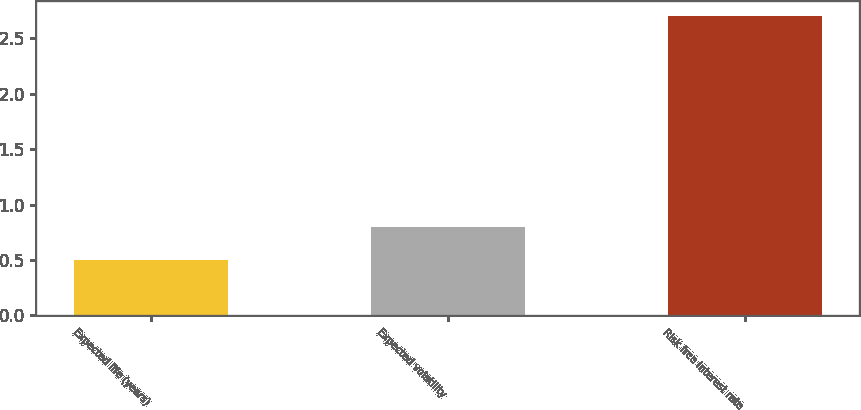<chart> <loc_0><loc_0><loc_500><loc_500><bar_chart><fcel>Expected life (years)<fcel>Expected volatility<fcel>Risk free interest rate<nl><fcel>0.5<fcel>0.8<fcel>2.7<nl></chart> 